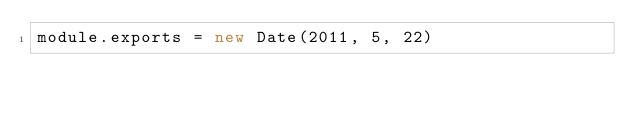Convert code to text. <code><loc_0><loc_0><loc_500><loc_500><_JavaScript_>module.exports = new Date(2011, 5, 22)
</code> 